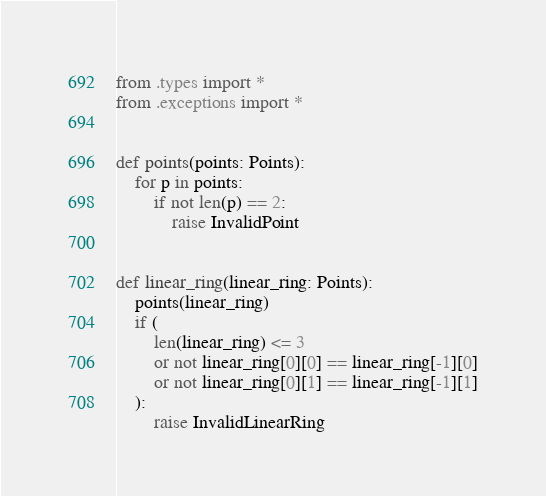<code> <loc_0><loc_0><loc_500><loc_500><_Python_>from .types import *
from .exceptions import *


def points(points: Points):
    for p in points:
        if not len(p) == 2:
            raise InvalidPoint


def linear_ring(linear_ring: Points):
    points(linear_ring)
    if (
        len(linear_ring) <= 3
        or not linear_ring[0][0] == linear_ring[-1][0]
        or not linear_ring[0][1] == linear_ring[-1][1]
    ):
        raise InvalidLinearRing</code> 